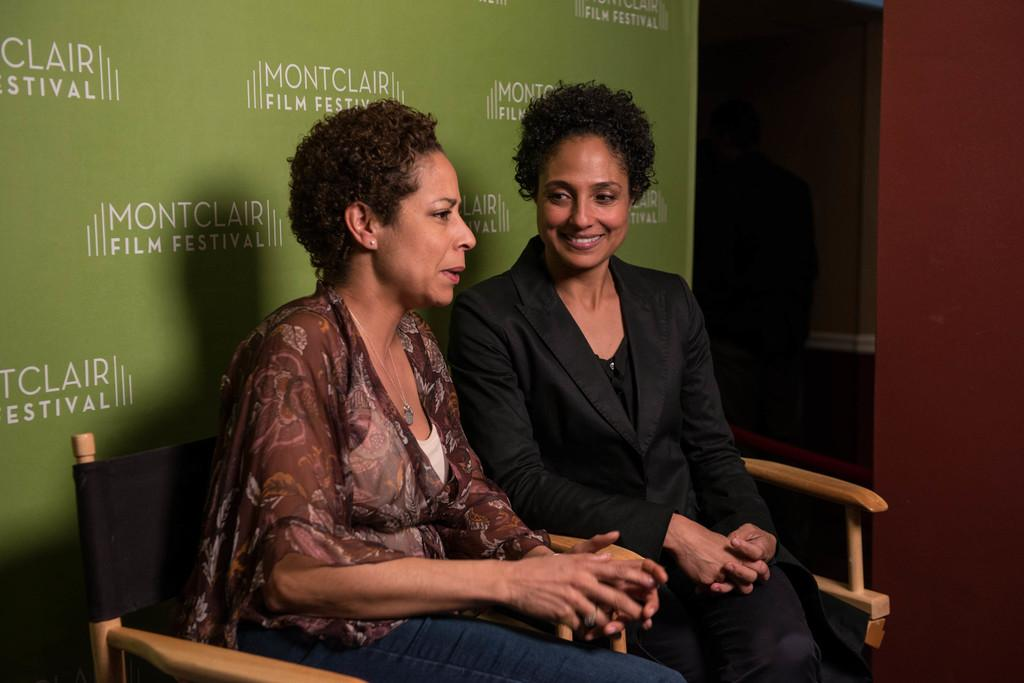How many people are in the image? There are two women in the image. What are the women doing in the image? The women are sitting on chairs. What can be seen behind the women in the image? There is a wall visible in the image. What type of hand gesture is the servant making in the image? There is no servant present in the image, and therefore no hand gesture can be observed. 